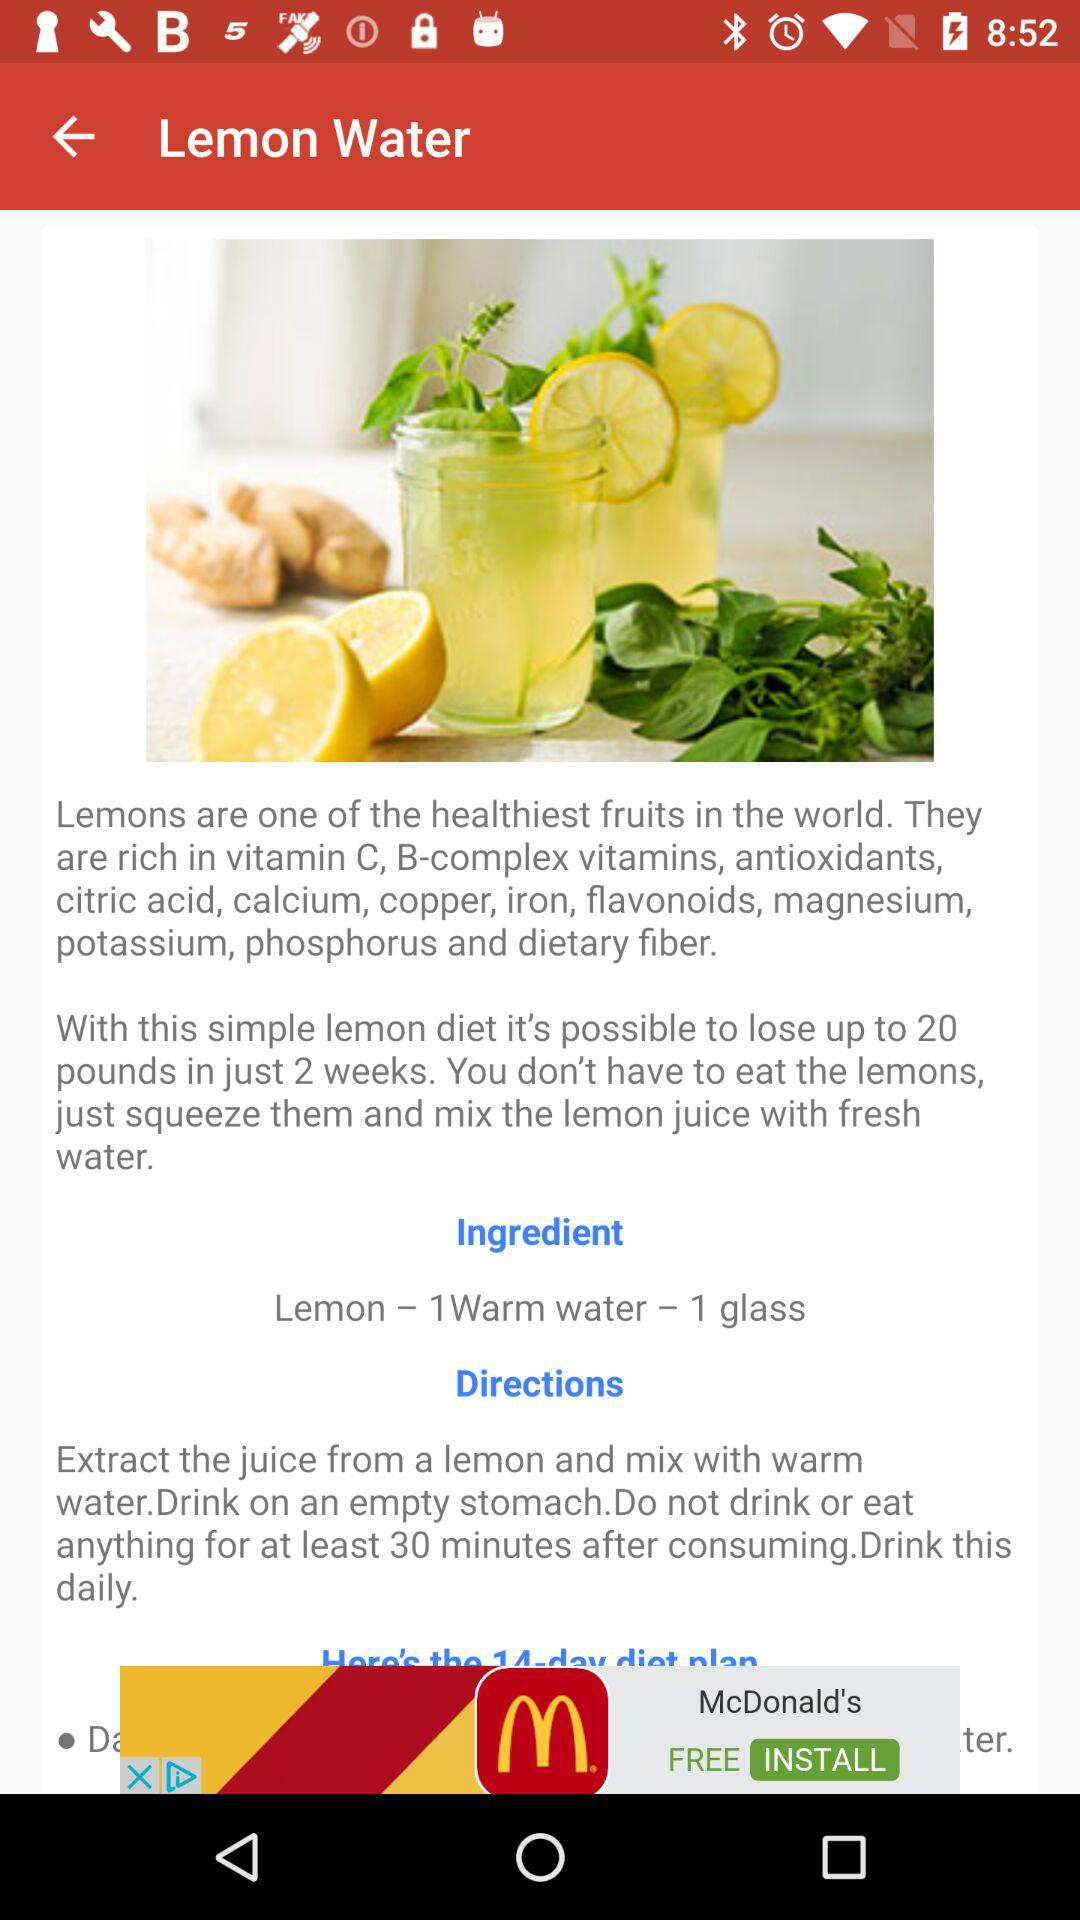What are the ingredients required? The ingredients required are "Lemon - 1Warm water - 1 glass". 